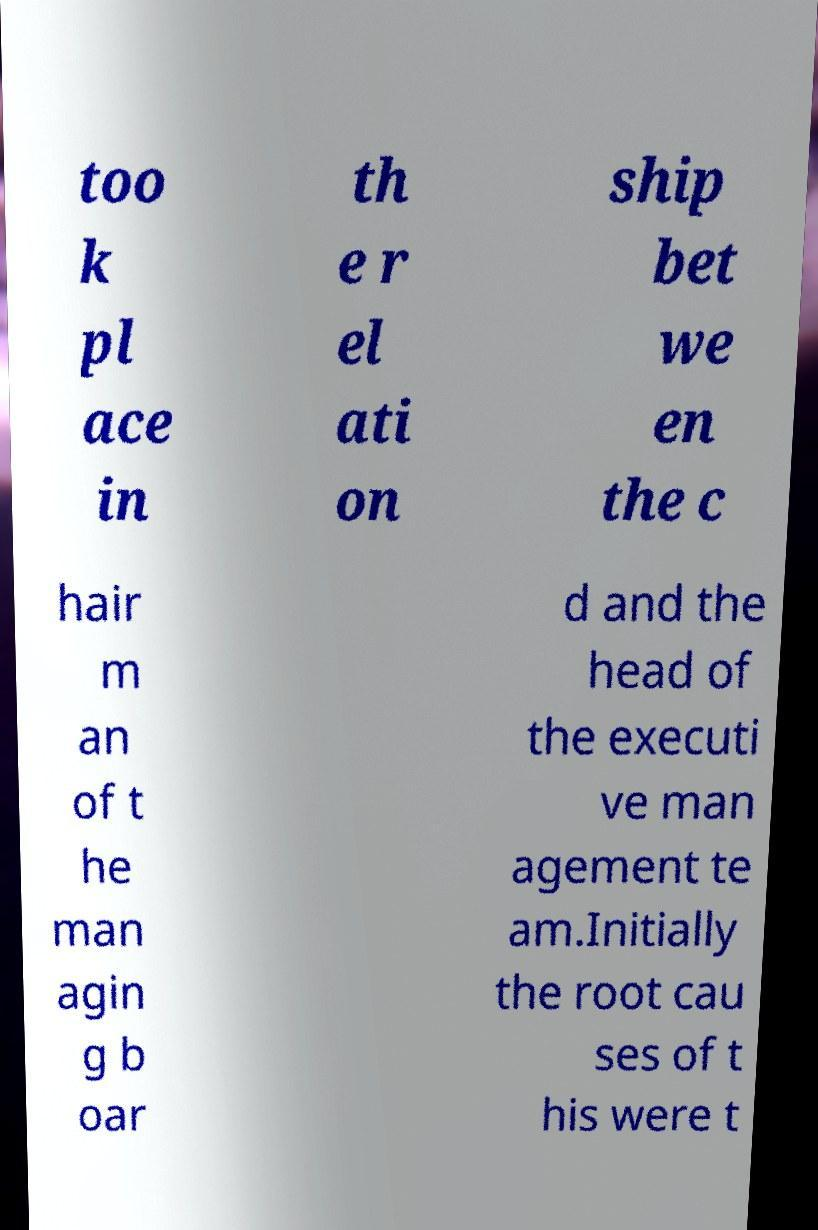Please identify and transcribe the text found in this image. too k pl ace in th e r el ati on ship bet we en the c hair m an of t he man agin g b oar d and the head of the executi ve man agement te am.Initially the root cau ses of t his were t 